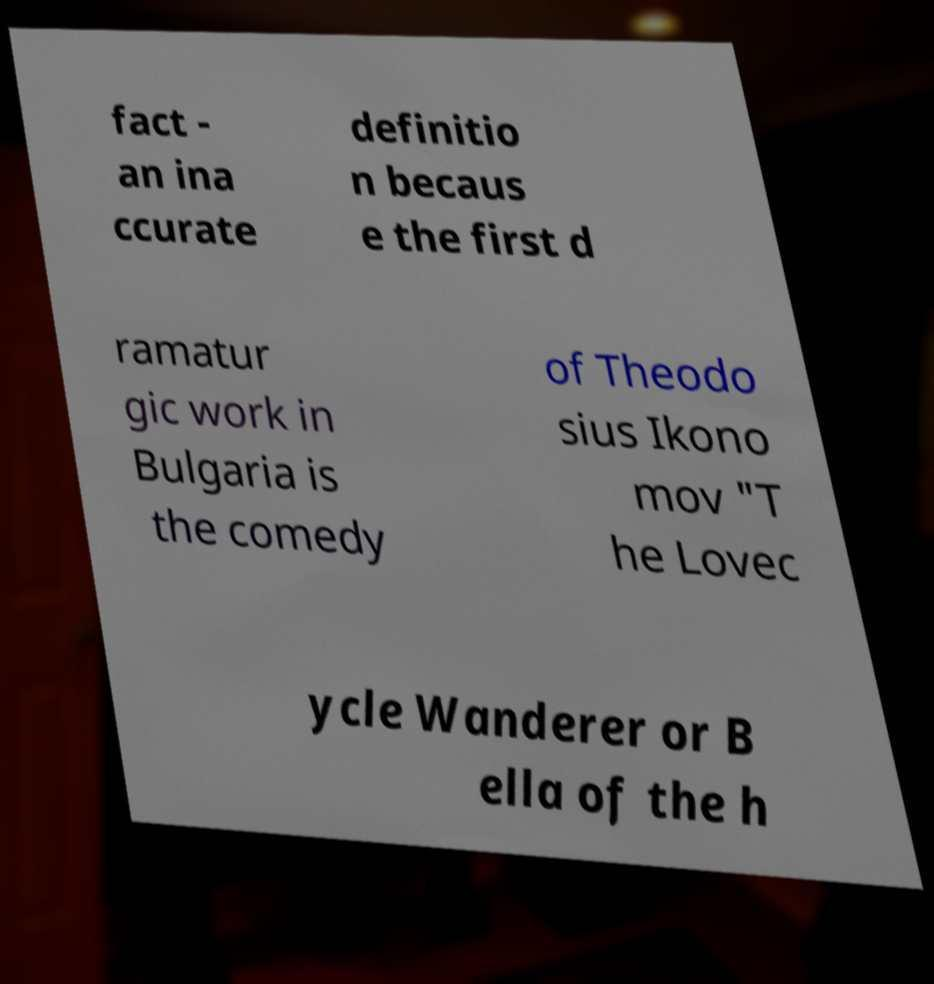Could you extract and type out the text from this image? fact - an ina ccurate definitio n becaus e the first d ramatur gic work in Bulgaria is the comedy of Theodo sius Ikono mov "T he Lovec ycle Wanderer or B ella of the h 